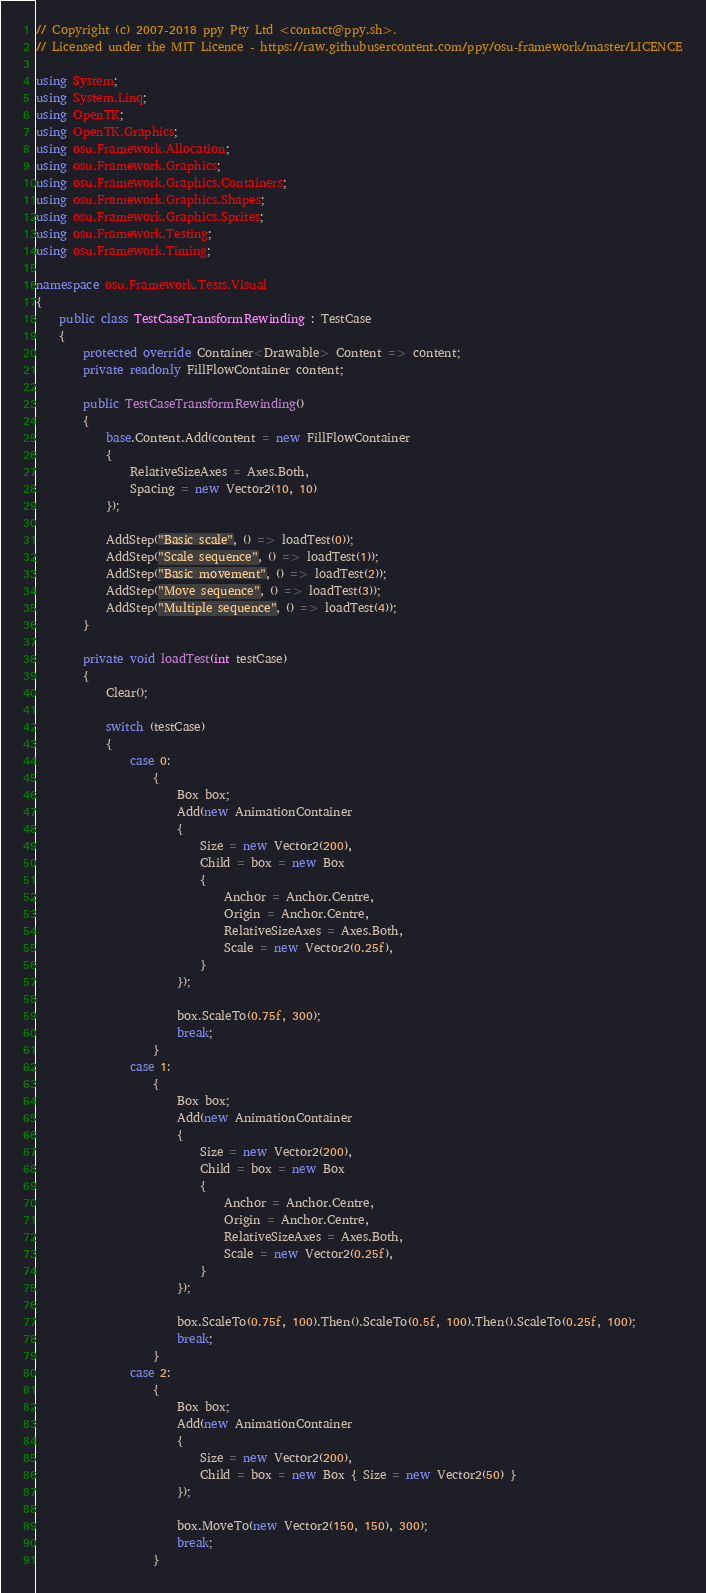Convert code to text. <code><loc_0><loc_0><loc_500><loc_500><_C#_>// Copyright (c) 2007-2018 ppy Pty Ltd <contact@ppy.sh>.
// Licensed under the MIT Licence - https://raw.githubusercontent.com/ppy/osu-framework/master/LICENCE

using System;
using System.Linq;
using OpenTK;
using OpenTK.Graphics;
using osu.Framework.Allocation;
using osu.Framework.Graphics;
using osu.Framework.Graphics.Containers;
using osu.Framework.Graphics.Shapes;
using osu.Framework.Graphics.Sprites;
using osu.Framework.Testing;
using osu.Framework.Timing;

namespace osu.Framework.Tests.Visual
{
    public class TestCaseTransformRewinding : TestCase
    {
        protected override Container<Drawable> Content => content;
        private readonly FillFlowContainer content;

        public TestCaseTransformRewinding()
        {
            base.Content.Add(content = new FillFlowContainer
            {
                RelativeSizeAxes = Axes.Both,
                Spacing = new Vector2(10, 10)
            });

            AddStep("Basic scale", () => loadTest(0));
            AddStep("Scale sequence", () => loadTest(1));
            AddStep("Basic movement", () => loadTest(2));
            AddStep("Move sequence", () => loadTest(3));
            AddStep("Multiple sequence", () => loadTest(4));
        }

        private void loadTest(int testCase)
        {
            Clear();

            switch (testCase)
            {
                case 0:
                    {
                        Box box;
                        Add(new AnimationContainer
                        {
                            Size = new Vector2(200),
                            Child = box = new Box
                            {
                                Anchor = Anchor.Centre,
                                Origin = Anchor.Centre,
                                RelativeSizeAxes = Axes.Both,
                                Scale = new Vector2(0.25f),
                            }
                        });

                        box.ScaleTo(0.75f, 300);
                        break;
                    }
                case 1:
                    {
                        Box box;
                        Add(new AnimationContainer
                        {
                            Size = new Vector2(200),
                            Child = box = new Box
                            {
                                Anchor = Anchor.Centre,
                                Origin = Anchor.Centre,
                                RelativeSizeAxes = Axes.Both,
                                Scale = new Vector2(0.25f),
                            }
                        });

                        box.ScaleTo(0.75f, 100).Then().ScaleTo(0.5f, 100).Then().ScaleTo(0.25f, 100);
                        break;
                    }
                case 2:
                    {
                        Box box;
                        Add(new AnimationContainer
                        {
                            Size = new Vector2(200),
                            Child = box = new Box { Size = new Vector2(50) }
                        });

                        box.MoveTo(new Vector2(150, 150), 300);
                        break;
                    }</code> 